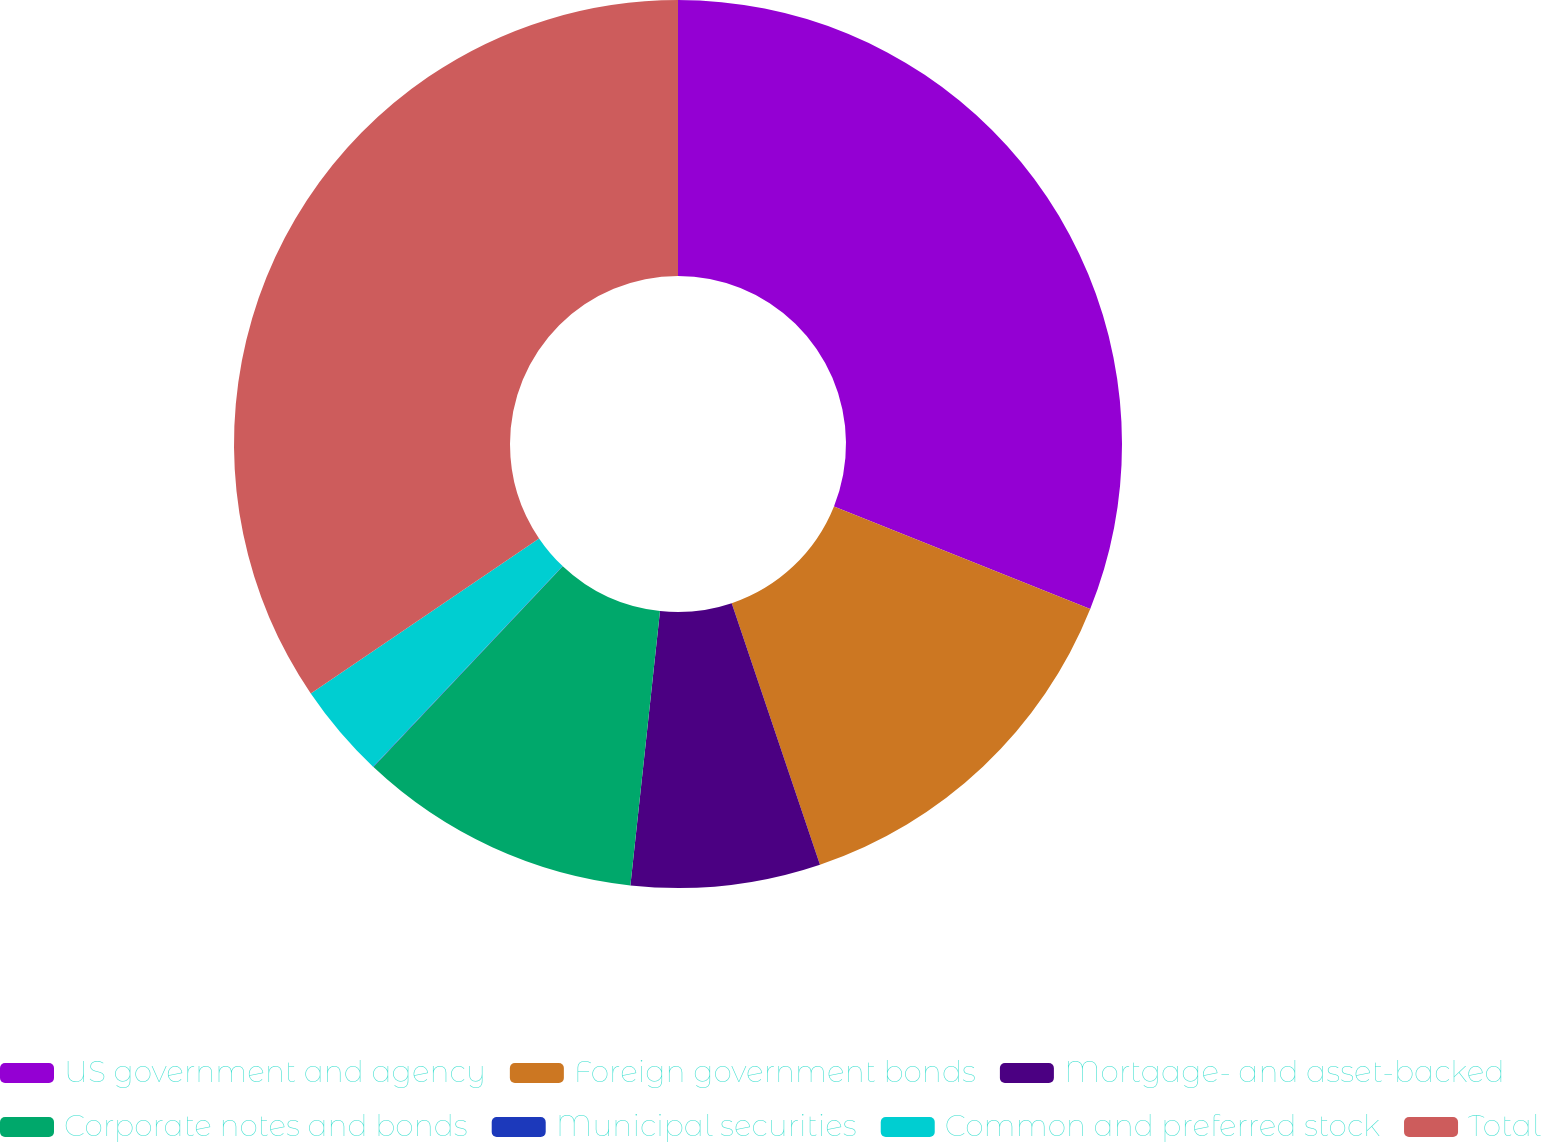Convert chart. <chart><loc_0><loc_0><loc_500><loc_500><pie_chart><fcel>US government and agency<fcel>Foreign government bonds<fcel>Mortgage- and asset-backed<fcel>Corporate notes and bonds<fcel>Municipal securities<fcel>Common and preferred stock<fcel>Total<nl><fcel>31.06%<fcel>13.76%<fcel>6.89%<fcel>10.32%<fcel>0.02%<fcel>3.45%<fcel>34.5%<nl></chart> 